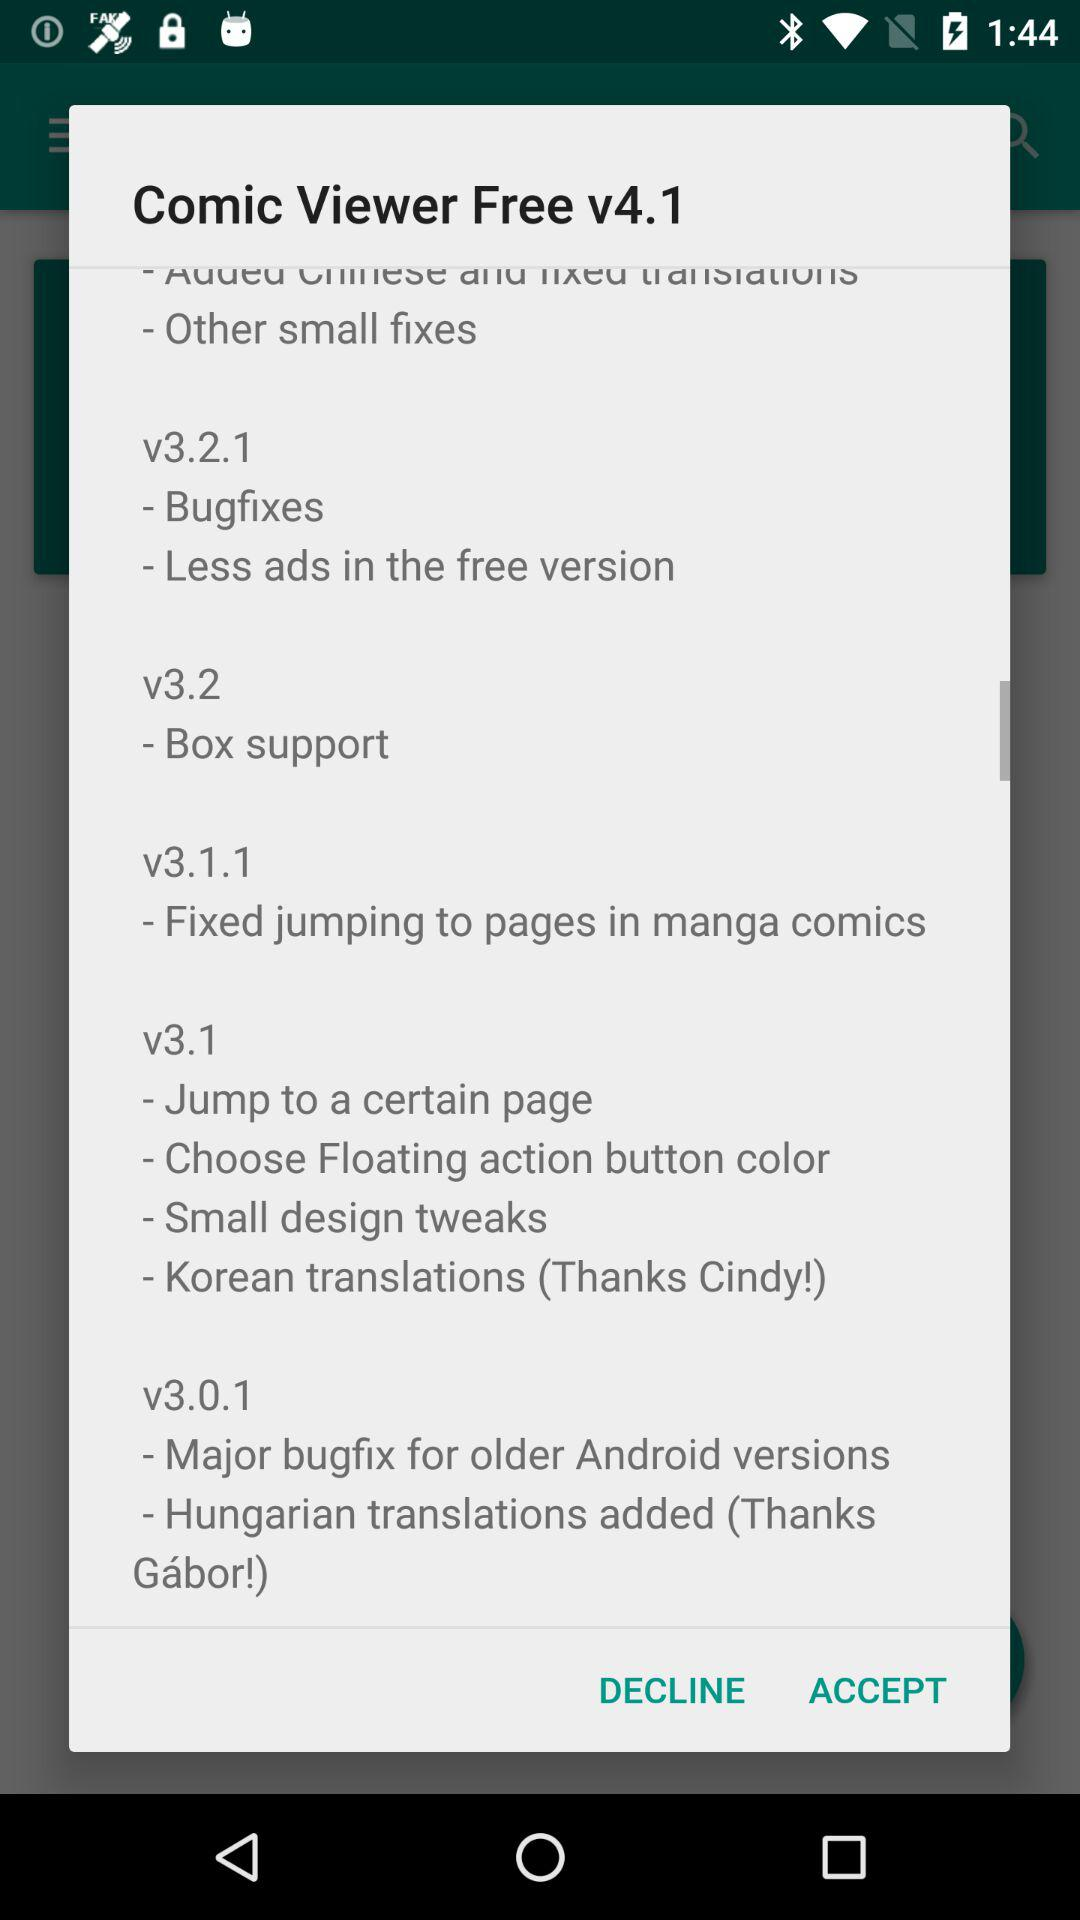What is the app name? The app name is "Comic Viewer". 